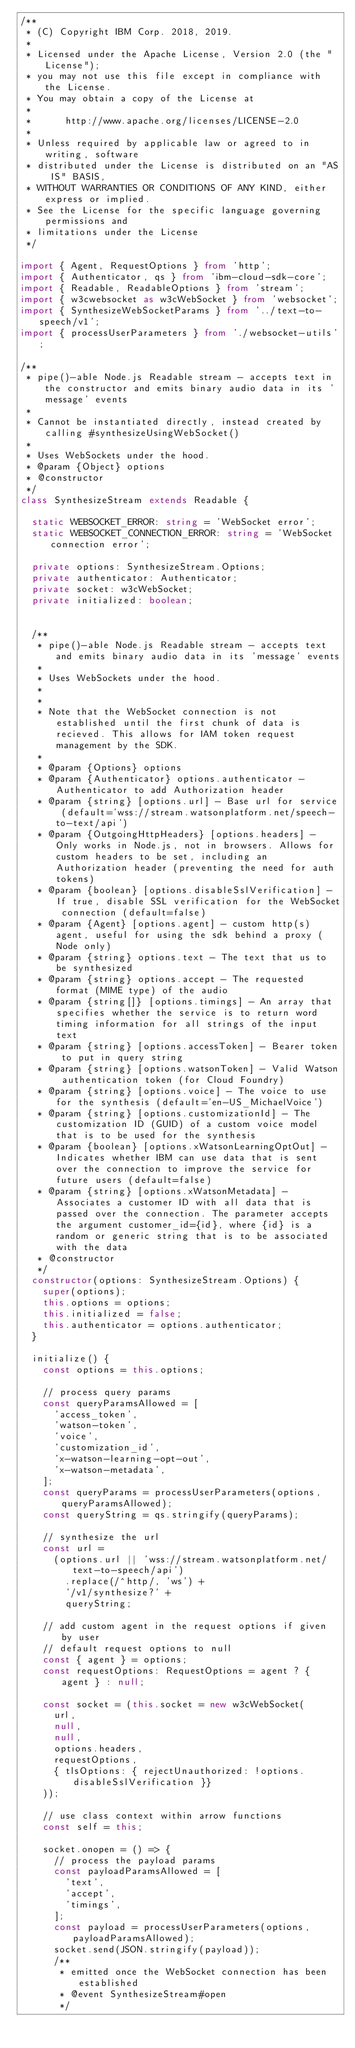Convert code to text. <code><loc_0><loc_0><loc_500><loc_500><_TypeScript_>/**
 * (C) Copyright IBM Corp. 2018, 2019.
 *
 * Licensed under the Apache License, Version 2.0 (the "License");
 * you may not use this file except in compliance with the License.
 * You may obtain a copy of the License at
 *
 *      http://www.apache.org/licenses/LICENSE-2.0
 *
 * Unless required by applicable law or agreed to in writing, software
 * distributed under the License is distributed on an "AS IS" BASIS,
 * WITHOUT WARRANTIES OR CONDITIONS OF ANY KIND, either express or implied.
 * See the License for the specific language governing permissions and
 * limitations under the License
 */

import { Agent, RequestOptions } from 'http';
import { Authenticator, qs } from 'ibm-cloud-sdk-core';
import { Readable, ReadableOptions } from 'stream';
import { w3cwebsocket as w3cWebSocket } from 'websocket';
import { SynthesizeWebSocketParams } from '../text-to-speech/v1';
import { processUserParameters } from './websocket-utils';

/**
 * pipe()-able Node.js Readable stream - accepts text in the constructor and emits binary audio data in its 'message' events
 *
 * Cannot be instantiated directly, instead created by calling #synthesizeUsingWebSocket()
 *
 * Uses WebSockets under the hood.
 * @param {Object} options
 * @constructor
 */
class SynthesizeStream extends Readable {

  static WEBSOCKET_ERROR: string = 'WebSocket error';
  static WEBSOCKET_CONNECTION_ERROR: string = 'WebSocket connection error';

  private options: SynthesizeStream.Options;
  private authenticator: Authenticator;
  private socket: w3cWebSocket;
  private initialized: boolean;


  /**
   * pipe()-able Node.js Readable stream - accepts text and emits binary audio data in its 'message' events
   *
   * Uses WebSockets under the hood.
   *
   *
   * Note that the WebSocket connection is not established until the first chunk of data is recieved. This allows for IAM token request management by the SDK.
   *
   * @param {Options} options
   * @param {Authenticator} options.authenticator - Authenticator to add Authorization header
   * @param {string} [options.url] - Base url for service (default='wss://stream.watsonplatform.net/speech-to-text/api')
   * @param {OutgoingHttpHeaders} [options.headers] - Only works in Node.js, not in browsers. Allows for custom headers to be set, including an Authorization header (preventing the need for auth tokens)
   * @param {boolean} [options.disableSslVerification] - If true, disable SSL verification for the WebSocket connection (default=false)
   * @param {Agent} [options.agent] - custom http(s) agent, useful for using the sdk behind a proxy (Node only)
   * @param {string} options.text - The text that us to be synthesized
   * @param {string} options.accept - The requested format (MIME type) of the audio
   * @param {string[]} [options.timings] - An array that specifies whether the service is to return word timing information for all strings of the input text
   * @param {string} [options.accessToken] - Bearer token to put in query string
   * @param {string} [options.watsonToken] - Valid Watson authentication token (for Cloud Foundry)
   * @param {string} [options.voice] - The voice to use for the synthesis (default='en-US_MichaelVoice')
   * @param {string} [options.customizationId] - The customization ID (GUID) of a custom voice model that is to be used for the synthesis
   * @param {boolean} [options.xWatsonLearningOptOut] - Indicates whether IBM can use data that is sent over the connection to improve the service for future users (default=false)
   * @param {string} [options.xWatsonMetadata] - Associates a customer ID with all data that is passed over the connection. The parameter accepts the argument customer_id={id}, where {id} is a random or generic string that is to be associated with the data
   * @constructor
   */
  constructor(options: SynthesizeStream.Options) {
    super(options);
    this.options = options;
    this.initialized = false;
    this.authenticator = options.authenticator;
  }

  initialize() {
    const options = this.options;

    // process query params
    const queryParamsAllowed = [
      'access_token',
      'watson-token',
      'voice',
      'customization_id',
      'x-watson-learning-opt-out',
      'x-watson-metadata',
    ];
    const queryParams = processUserParameters(options, queryParamsAllowed);
    const queryString = qs.stringify(queryParams);

    // synthesize the url
    const url =
      (options.url || 'wss://stream.watsonplatform.net/text-to-speech/api')
        .replace(/^http/, 'ws') +
        '/v1/synthesize?' +
        queryString;

    // add custom agent in the request options if given by user
    // default request options to null
    const { agent } = options;
    const requestOptions: RequestOptions = agent ? { agent } : null;

    const socket = (this.socket = new w3cWebSocket(
      url,
      null,
      null,
      options.headers,
      requestOptions,
      { tlsOptions: { rejectUnauthorized: !options.disableSslVerification }}
    ));

    // use class context within arrow functions
    const self = this;

    socket.onopen = () => {
      // process the payload params
      const payloadParamsAllowed = [
        'text',
        'accept',
        'timings',
      ];
      const payload = processUserParameters(options, payloadParamsAllowed);
      socket.send(JSON.stringify(payload));
      /**
       * emitted once the WebSocket connection has been established
       * @event SynthesizeStream#open
       */</code> 